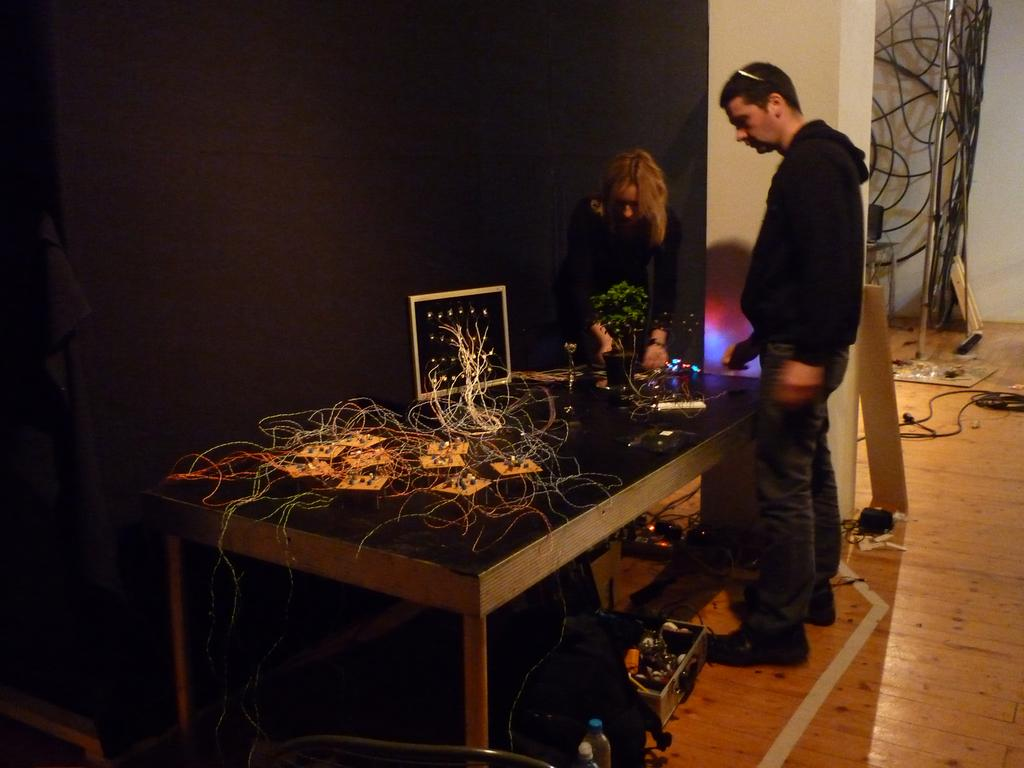How many people are present in the image? There are two people in the image, a man and a woman. What is the woman holding in her hand? The woman is holding a plant in her hand. What objects can be seen on the table in the image? There are circuit boards on the table in the image. What type of creature is pulling the carriage in the image? There is no carriage present in the image, so it is not possible to answer that question. 